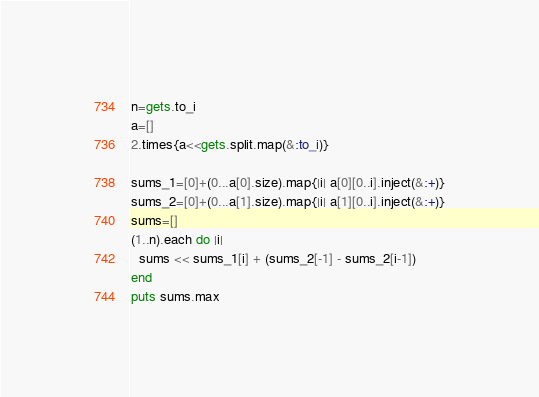Convert code to text. <code><loc_0><loc_0><loc_500><loc_500><_Ruby_>n=gets.to_i
a=[]
2.times{a<<gets.split.map(&:to_i)}

sums_1=[0]+(0...a[0].size).map{|i| a[0][0..i].inject(&:+)}
sums_2=[0]+(0...a[1].size).map{|i| a[1][0..i].inject(&:+)}
sums=[]
(1..n).each do |i|
  sums << sums_1[i] + (sums_2[-1] - sums_2[i-1])
end
puts sums.max
</code> 